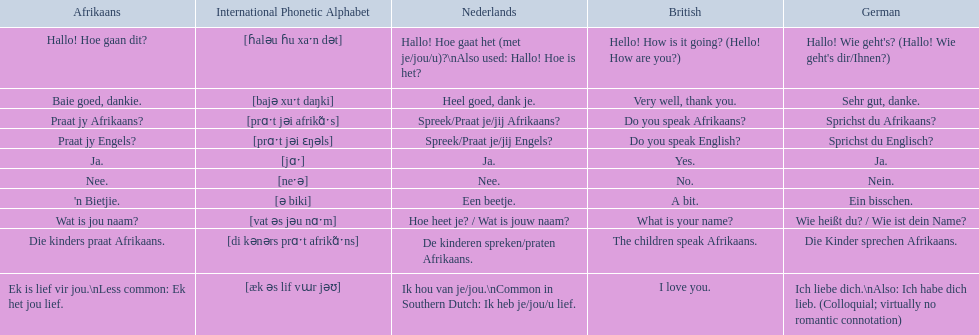How do you say do you speak english in german? Sprichst du Englisch?. What about do you speak afrikaanss? in afrikaans? Praat jy Afrikaans?. 